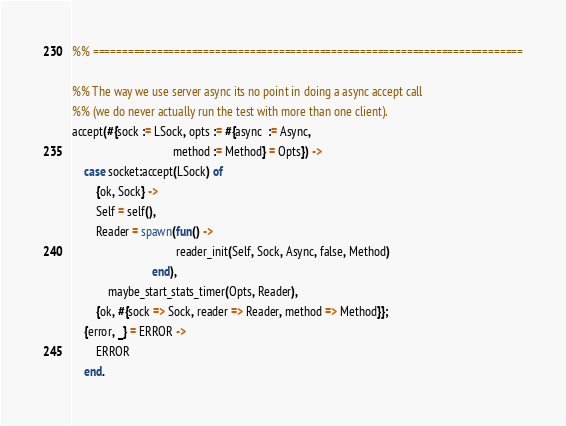Convert code to text. <code><loc_0><loc_0><loc_500><loc_500><_Erlang_>
%% ==========================================================================

%% The way we use server async its no point in doing a async accept call
%% (we do never actually run the test with more than one client).
accept(#{sock := LSock, opts := #{async  := Async,
                                  method := Method} = Opts}) ->
    case socket:accept(LSock) of
        {ok, Sock} ->
	    Self = self(),
	    Reader = spawn(fun() ->
                                   reader_init(Self, Sock, Async, false, Method)
                           end),
            maybe_start_stats_timer(Opts, Reader),
	    {ok, #{sock => Sock, reader => Reader, method => Method}};
	{error, _} = ERROR ->
	    ERROR
    end.
</code> 